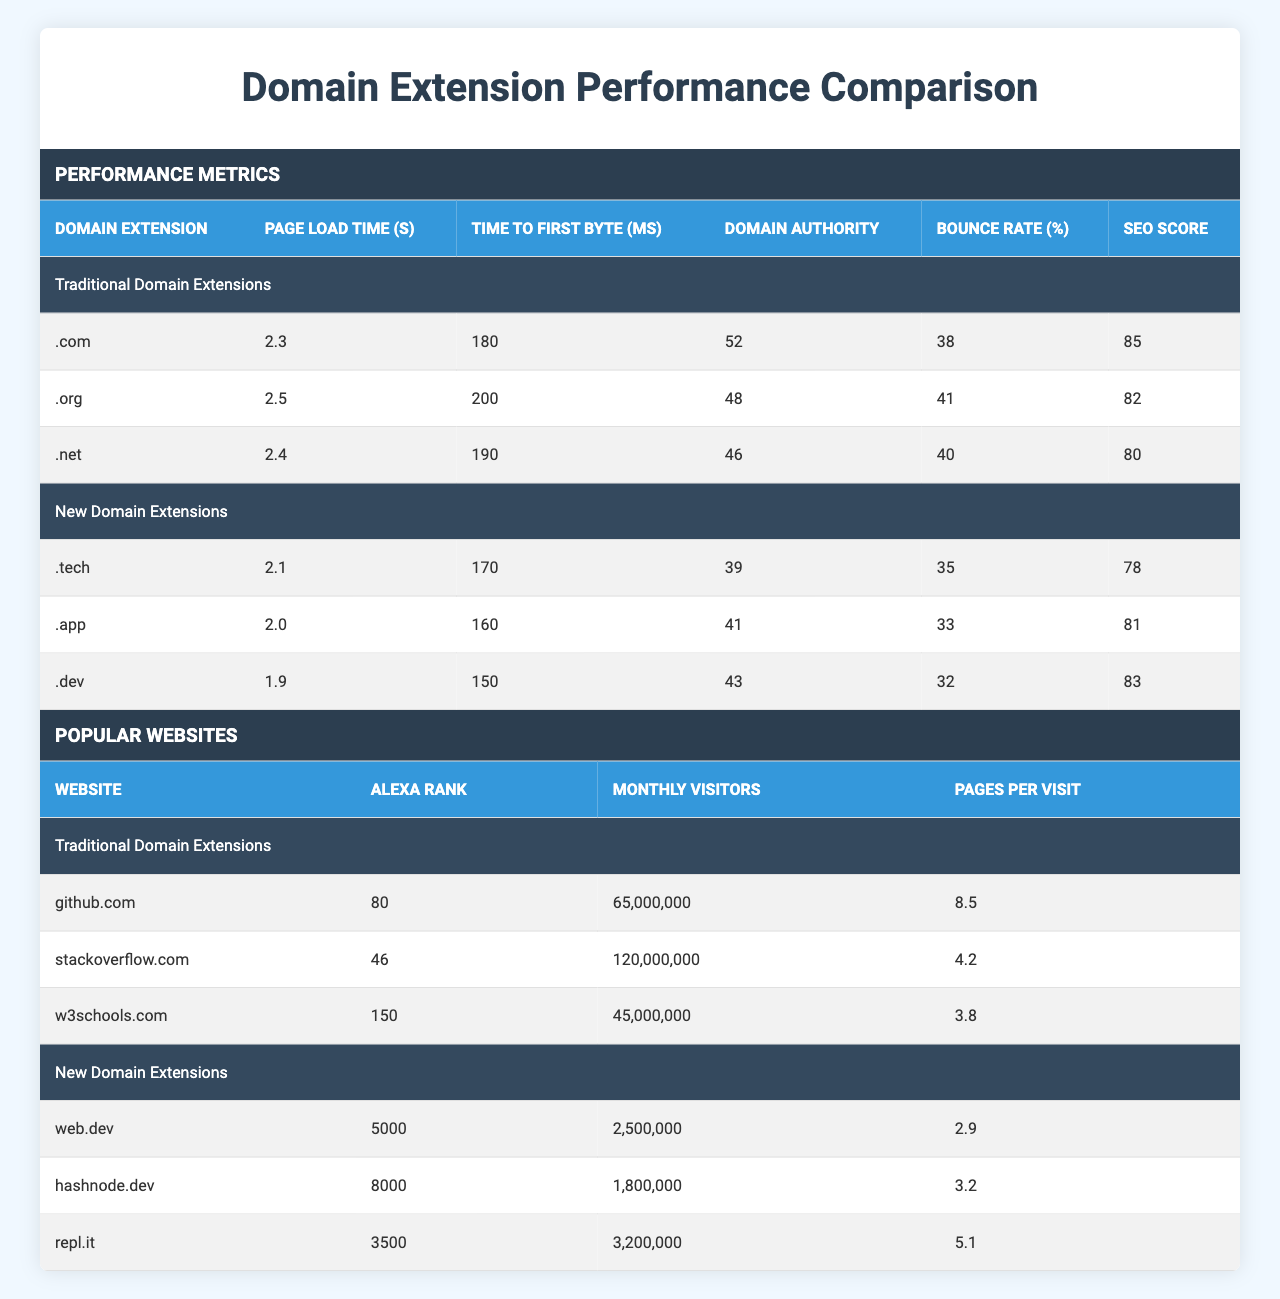What is the page load time for the .app domain extension? The table indicates that the page load time for the .app domain extension is 2.0 seconds.
Answer: 2.0 seconds Which traditional domain extension has the highest domain authority? By examining the table, it shows that the .com domain extension has the highest domain authority at 52.
Answer: .com What is the average bounce rate for websites using traditional domain extensions? The bounce rates for traditional extensions are 38%, 41%, and 40% for .com, .org, and .net respectively. The average is (38 + 41 + 40) / 3 = 39.67%.
Answer: 39.67% Is the bounce rate for the .dev domain extension lower than that of the .org extension? The bounce rate for the .dev extension is 32% while for the .org extension it is 41%. Since 32% is less than 41%, the statement is true.
Answer: Yes How does the page load time of the fastest new domain extension compare to the slowest traditional domain extension? The fastest new domain extension is .dev with a page load time of 1.9 seconds, while the slowest traditional extension is .org with a page load time of 2.5 seconds. Comparing these, 1.9 seconds is less than 2.5 seconds, indicating that the .dev extension loads faster.
Answer: .dev is faster What is the difference in time to first byte between the .tech and .net domain extensions? The time to first byte for .tech is 170 ms and for .net is 190 ms. The difference is 190 - 170 = 20 ms, indicating that .tech responds faster.
Answer: 20 ms Which new domain extension has the highest number of monthly visitors, and what is that number? The .dev extension has 3,200,000 monthly visitors, which is the highest among new domain extensions, compared to .tech and .app.
Answer: 3,200,000 What is the total number of monthly visitors for the popular websites using traditional domain extensions listed in the table? The total monthly visitors for the traditional websites are 65,000,000 (github.com) + 120,000,000 (stackoverflow.com) + 45,000,000 (w3schools.com) = 230,000,000.
Answer: 230,000,000 Are there any new domain extensions with a domain authority greater than 40? The table shows that both .app (41) and .dev (43) have domain authorities greater than 40, confirming that there are such extensions.
Answer: Yes Which has a lower SEO score, the highest traditional domain extension or the lowest new domain extension? The highest SEO score among traditional extensions is 85 (for .com) and the lowest among new extensions is 78 (for .tech). Since 78 is lower than 85, the lowest new extension has a lower score.
Answer: Lowest new extension How many total pages per visit do the popular websites using new domain extensions average? The pages per visit for the new domain websites are 2.9 (web.dev), 3.2 (hashnode.dev), and 5.1 (repl.it). The average is (2.9 + 3.2 + 5.1) / 3 = 3.73 pages per visit.
Answer: 3.73 pages per visit 